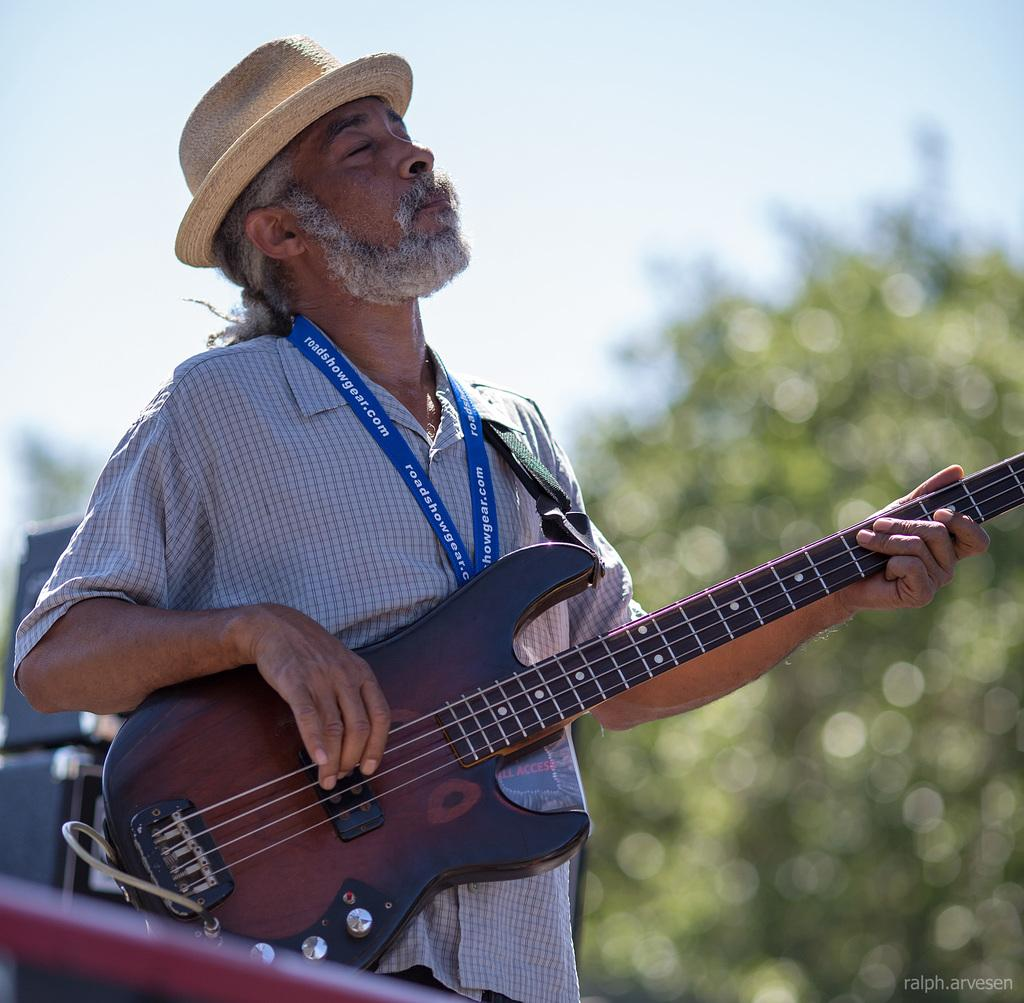Who is present in the image? There is a man in the image. What is the man wearing on his head? The man is wearing a hat. What object is the man holding in the image? The man is holding a guitar. What type of toys can be seen in the image? There are no toys present in the image; it features a man wearing a hat and holding a guitar. 